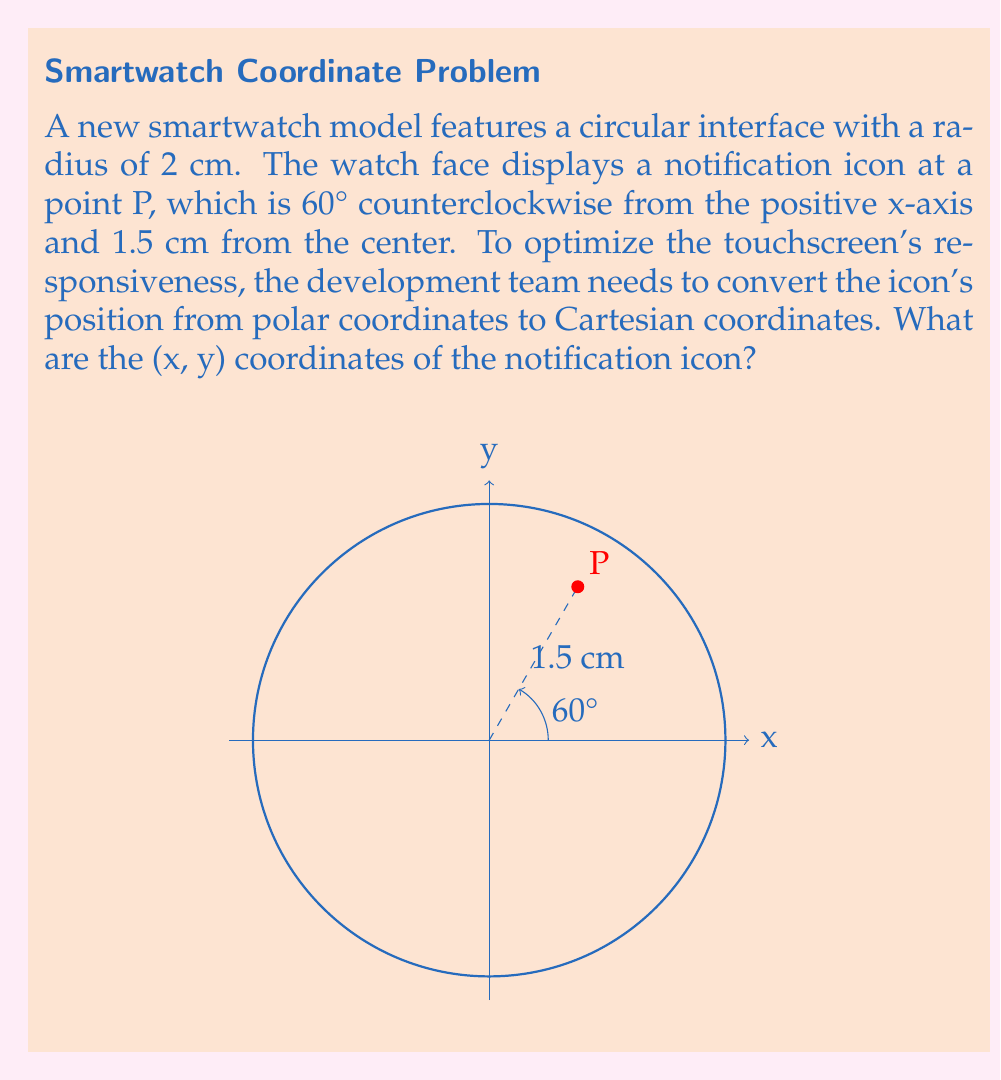Solve this math problem. To convert from polar coordinates $(r, \theta)$ to Cartesian coordinates $(x, y)$, we use these formulas:

$$x = r \cos(\theta)$$
$$y = r \sin(\theta)$$

Given:
- Radius (r) = 1.5 cm
- Angle ($\theta$) = 60°

Step 1: Calculate x-coordinate
$$x = 1.5 \cos(60°)$$
$$x = 1.5 \times 0.5 = 0.75 \text{ cm}$$

Step 2: Calculate y-coordinate
$$y = 1.5 \sin(60°)$$
$$y = 1.5 \times \frac{\sqrt{3}}{2} \approx 1.299 \text{ cm}$$

Therefore, the Cartesian coordinates of the notification icon are approximately (0.75 cm, 1.299 cm).
Answer: (0.75 cm, 1.299 cm) 